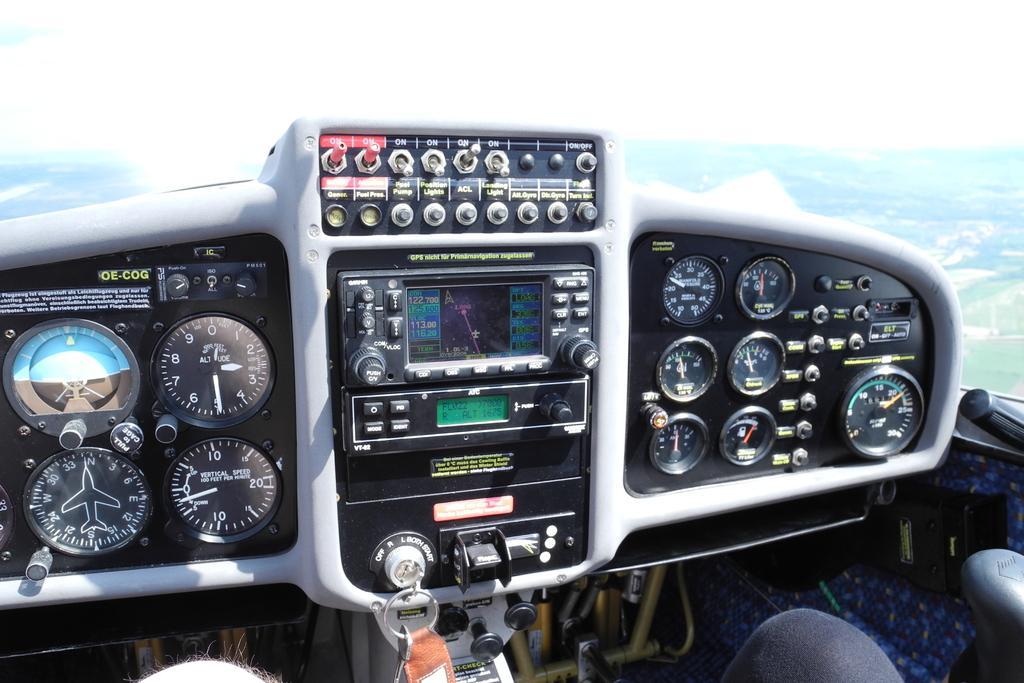How would you summarize this image in a sentence or two? In this image we can see an inside of an airplane, there is a screen, there is text and number on the screen, there are keys towards the bottom of the image, there are persons legs towards the bottom of the image, there is the sky towards the top of the image, there are buttons. 